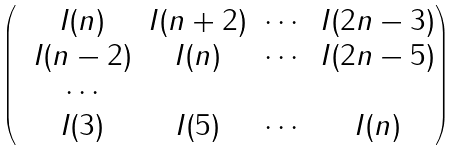<formula> <loc_0><loc_0><loc_500><loc_500>\begin{pmatrix} & I ( n ) & I ( n + 2 ) & \cdots & I ( 2 n - 3 ) \\ & I ( n - 2 ) & I ( n ) & \cdots & I ( 2 n - 5 ) \\ & \cdots \\ & I ( 3 ) & I ( 5 ) & \cdots & I ( n ) \end{pmatrix}</formula> 